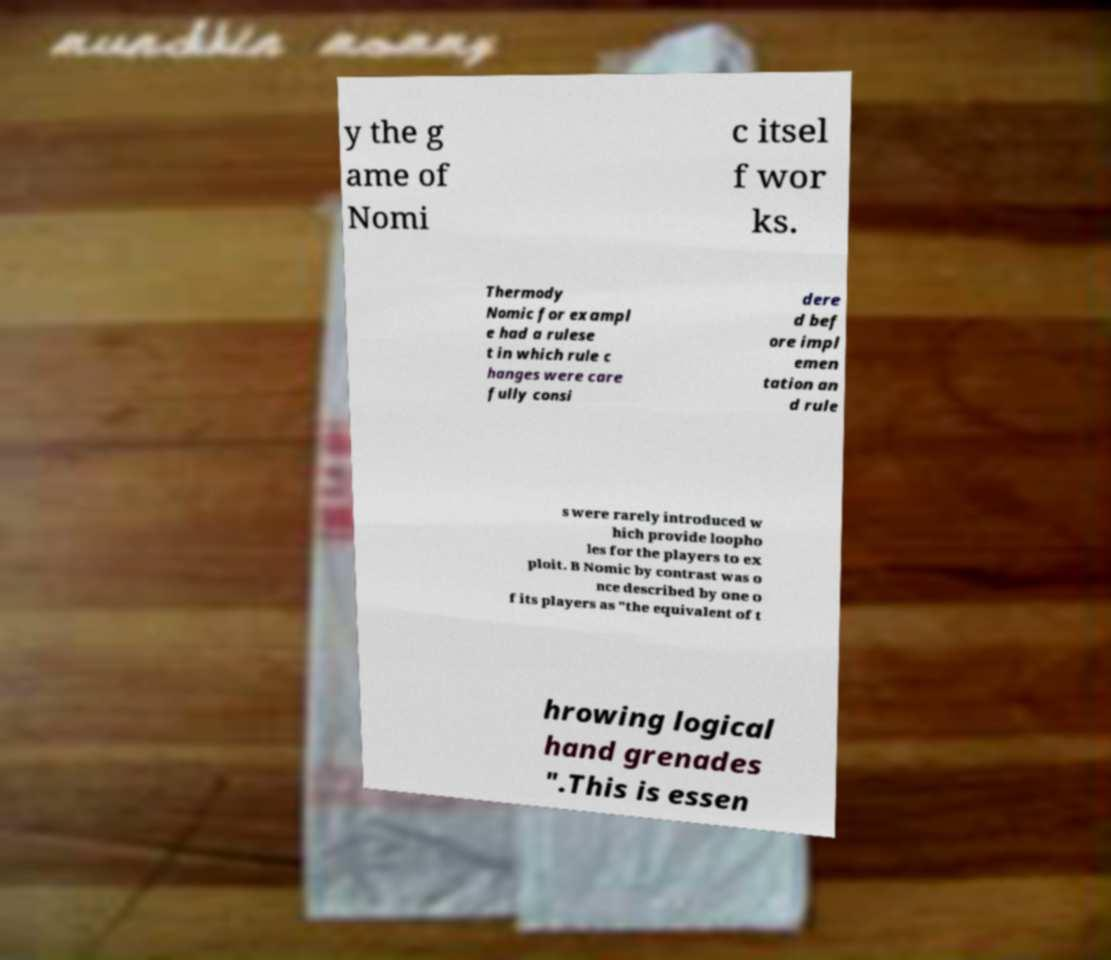Could you extract and type out the text from this image? y the g ame of Nomi c itsel f wor ks. Thermody Nomic for exampl e had a rulese t in which rule c hanges were care fully consi dere d bef ore impl emen tation an d rule s were rarely introduced w hich provide loopho les for the players to ex ploit. B Nomic by contrast was o nce described by one o f its players as "the equivalent of t hrowing logical hand grenades ".This is essen 